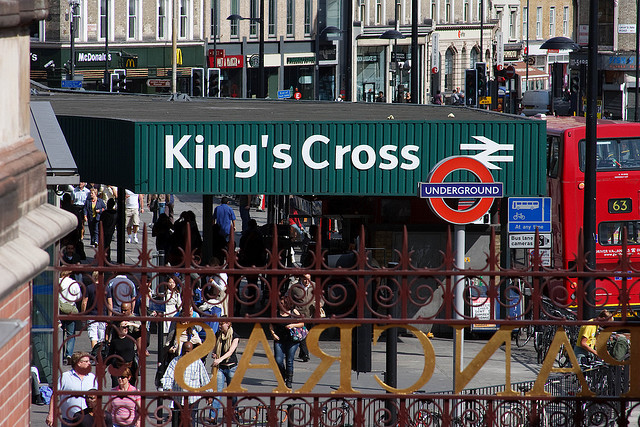<image>What natural force is demonstrated most clearly in this series of pictures? It's ambiguous what natural force is demonstrated most clearly in this series of pictures. It could be gravity or wind. What natural force is demonstrated most clearly in this series of pictures? The natural force demonstrated most clearly in this series of pictures is gravity. 